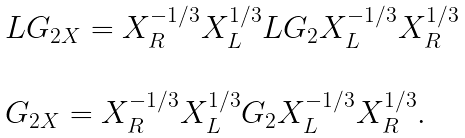<formula> <loc_0><loc_0><loc_500><loc_500>\begin{array} { l } L G _ { 2 X } = X ^ { - 1 / 3 } _ { R } X ^ { 1 / 3 } _ { L } L G _ { 2 } X ^ { - 1 / 3 } _ { L } X ^ { 1 / 3 } _ { R } \\ \\ G _ { 2 X } = X ^ { - 1 / 3 } _ { R } X ^ { 1 / 3 } _ { L } G _ { 2 } X ^ { - 1 / 3 } _ { L } X ^ { 1 / 3 } _ { R } . \\ \\ \end{array}</formula> 